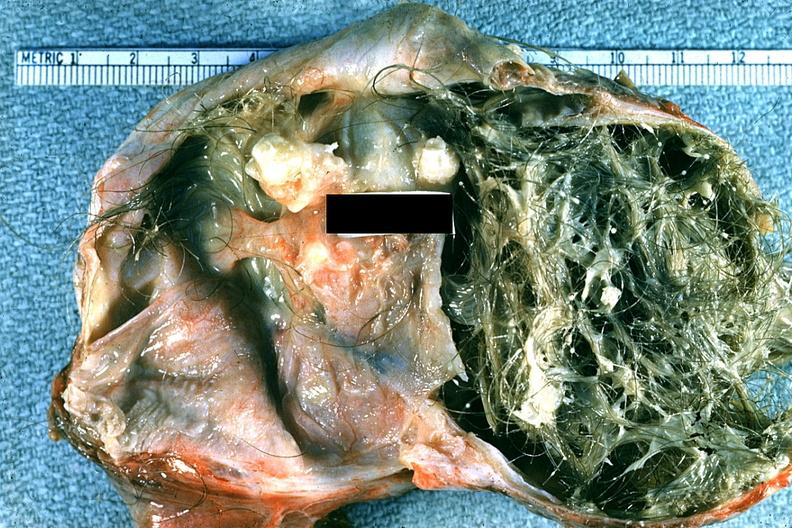s benign cystic teratoma present?
Answer the question using a single word or phrase. Yes 